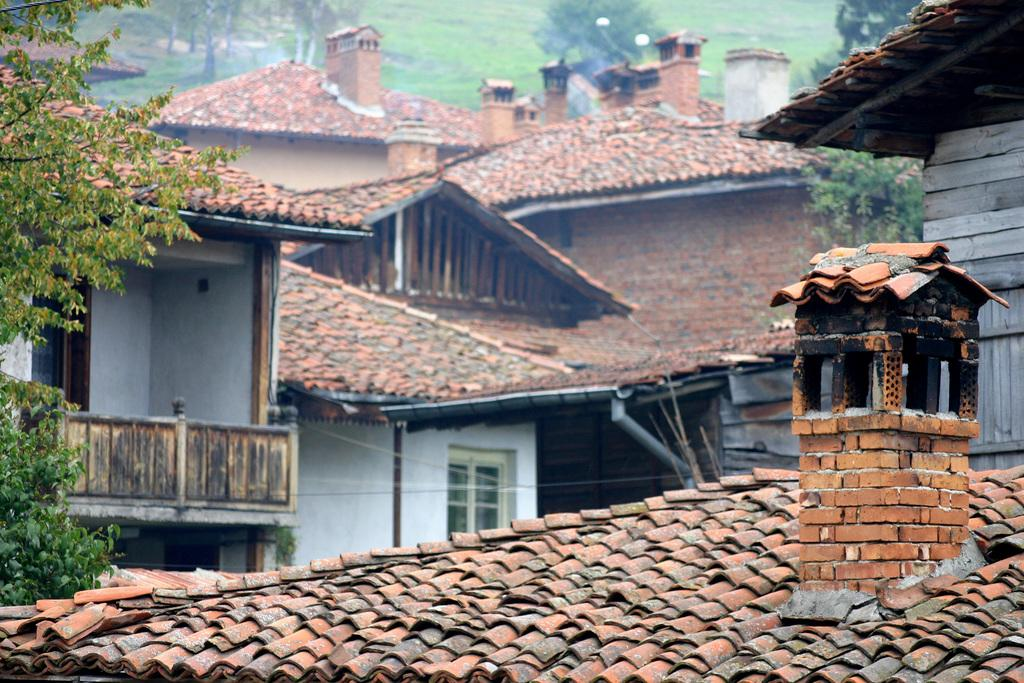What type of structures can be seen in the image? There are houses in the image. What type of vegetation is present in the image? There are trees in the image. What type of ground cover is visible behind the houses? Grass is present on the surface behind the houses. What type of wrench is being used by the army in the image? There is no wrench or army present in the image. What emotion is being displayed by the houses in the image? Houses do not display emotions, so it is not possible to determine if they are feeling shame or any other emotion. 